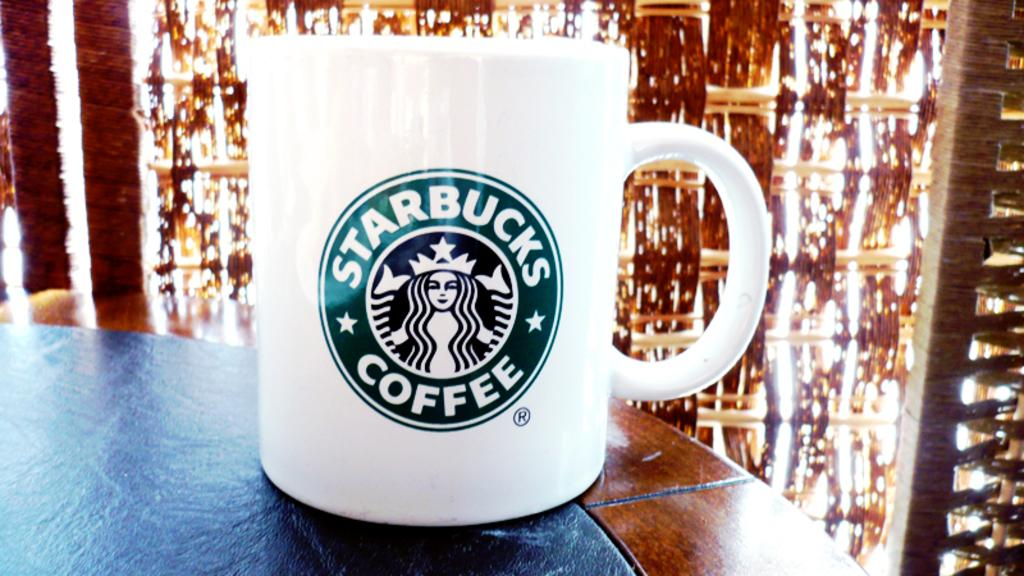Provide a one-sentence caption for the provided image. a cup that has the word coffee on it. 